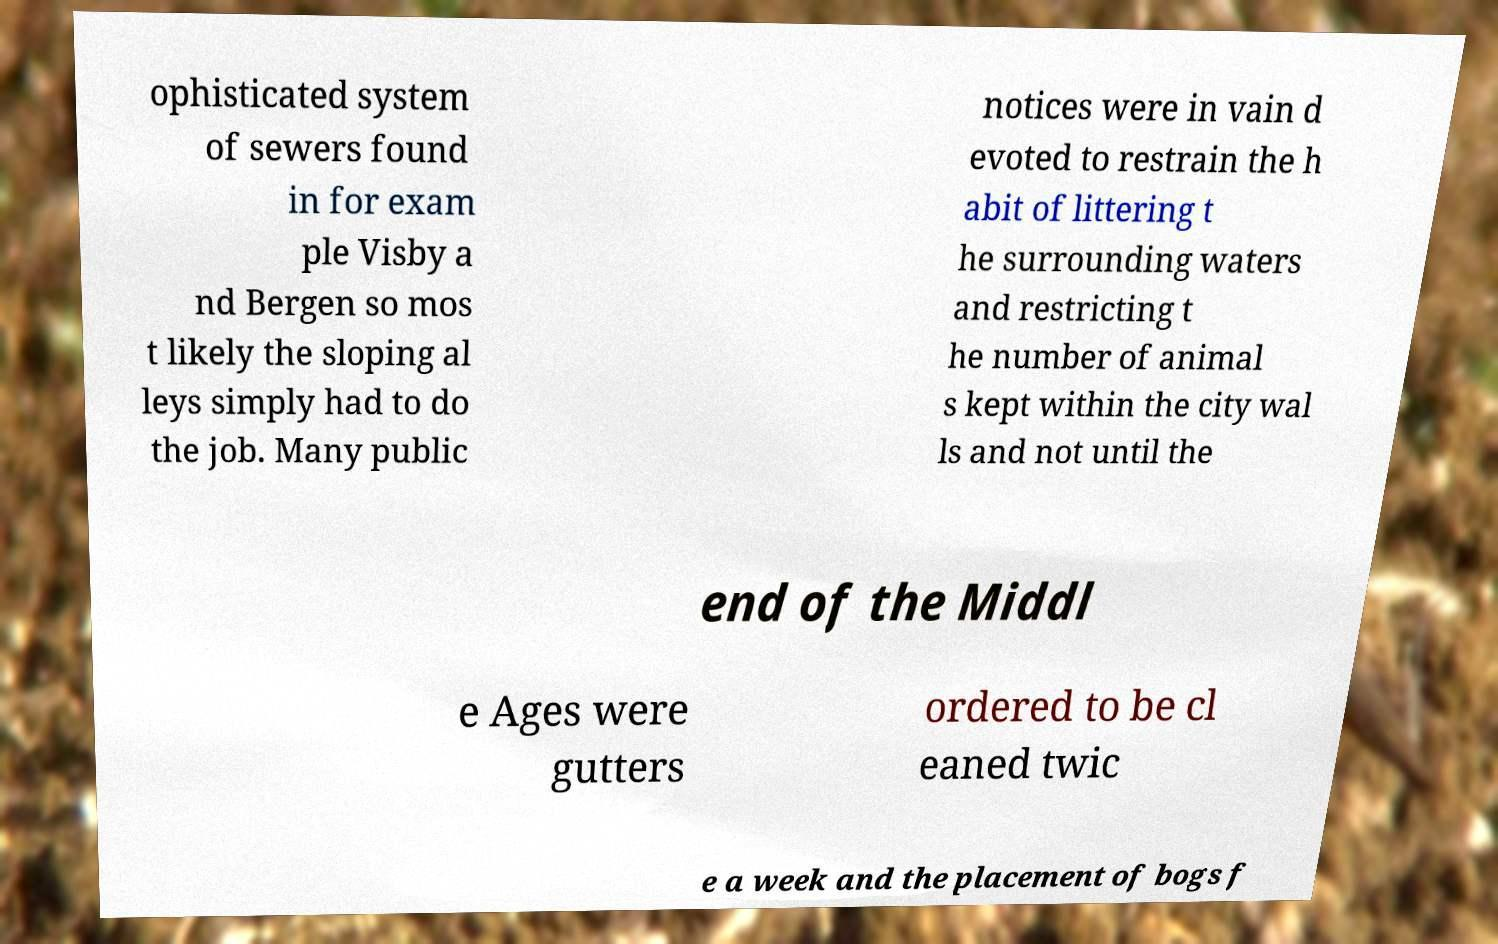For documentation purposes, I need the text within this image transcribed. Could you provide that? ophisticated system of sewers found in for exam ple Visby a nd Bergen so mos t likely the sloping al leys simply had to do the job. Many public notices were in vain d evoted to restrain the h abit of littering t he surrounding waters and restricting t he number of animal s kept within the city wal ls and not until the end of the Middl e Ages were gutters ordered to be cl eaned twic e a week and the placement of bogs f 